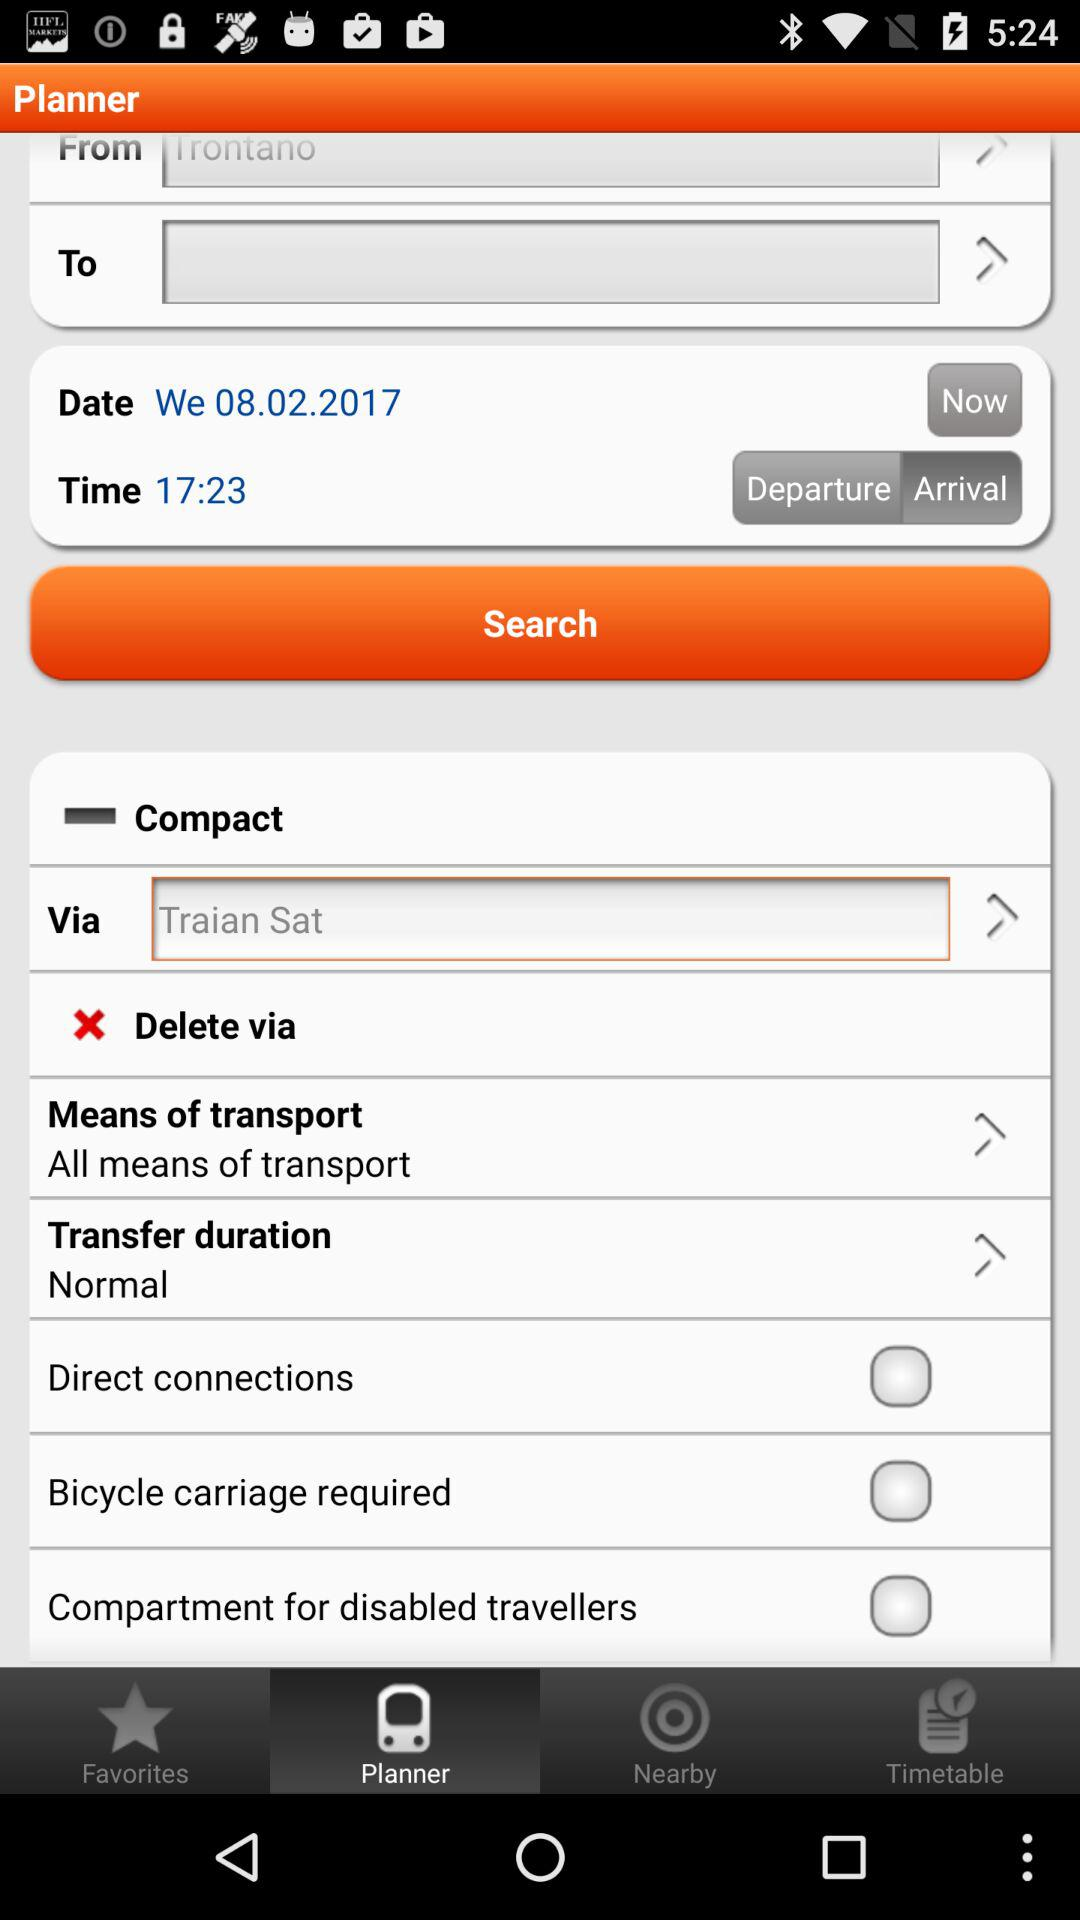What is the status of the "Compartment for disabled travellers"? The status is "off". 